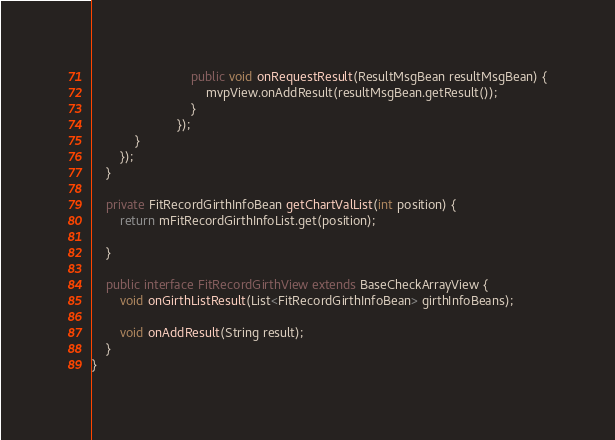<code> <loc_0><loc_0><loc_500><loc_500><_Java_>                            public void onRequestResult(ResultMsgBean resultMsgBean) {
                                mvpView.onAddResult(resultMsgBean.getResult());
                            }
                        });
            }
        });
    }

    private FitRecordGirthInfoBean getChartValList(int position) {
        return mFitRecordGirthInfoList.get(position);

    }

    public interface FitRecordGirthView extends BaseCheckArrayView {
        void onGirthListResult(List<FitRecordGirthInfoBean> girthInfoBeans);

        void onAddResult(String result);
    }
}
</code> 